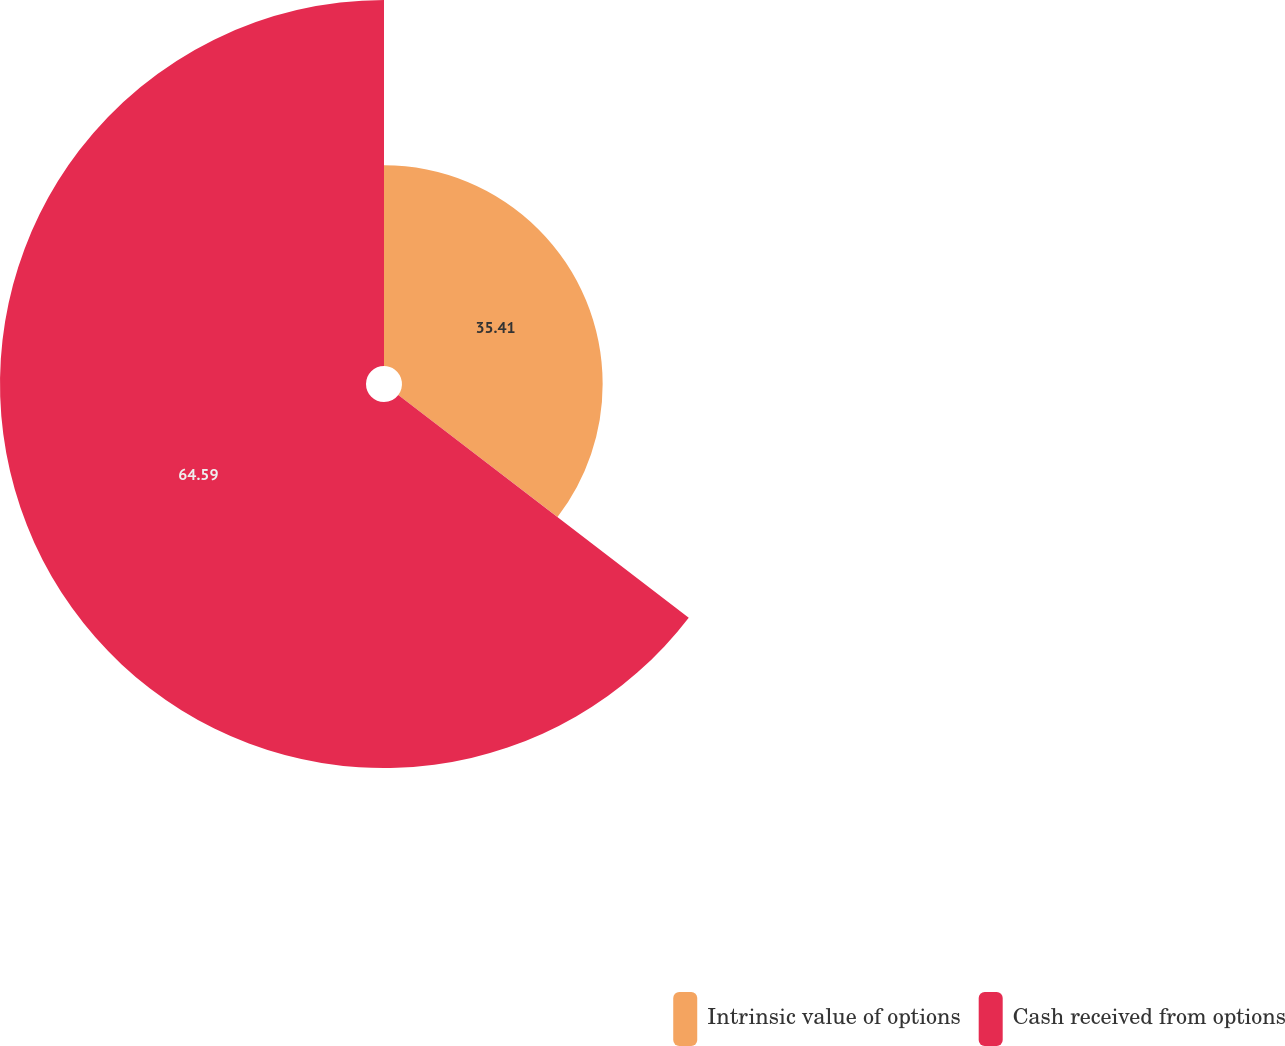Convert chart to OTSL. <chart><loc_0><loc_0><loc_500><loc_500><pie_chart><fcel>Intrinsic value of options<fcel>Cash received from options<nl><fcel>35.41%<fcel>64.59%<nl></chart> 